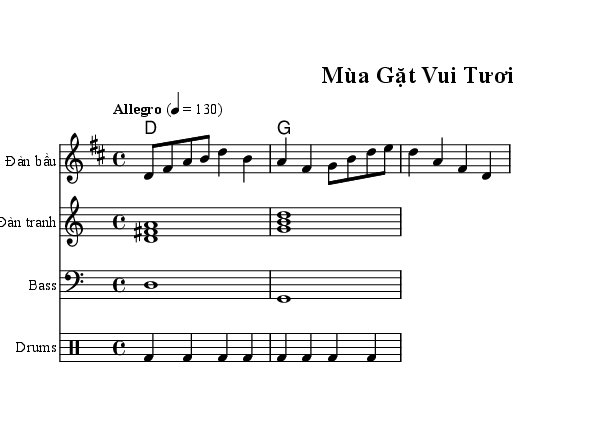What is the title of this music? The title is clearly indicated at the top of the sheet music under the header section. It reads "Mùa Gặt Vui Tươi".
Answer: Mùa Gặt Vui Tươi What is the key signature of this music? The key signature is located in the global definition of the music. The notation specifies "d" which indicates it is in D major.
Answer: D major What is the time signature of this music? The time signature is also found in the global section of the music, where it states "4/4", indicating four beats per measure.
Answer: 4/4 What is the tempo marking of this music? The tempo marking is indicated in the global section as "Allegro" with a metronome marking of "4 = 130", suggesting it should be played fast at 130 beats per minute.
Answer: Allegro, 130 How many measures are in the melody? To determine the number of measures, we need to count the number of sections separated by vertical lines in the melody part. The melody consists of 2 measures as indicated by the notations.
Answer: 2 Which instrument is shown playing the melody? The instrument playing the melody is specified in the staff label which indicates it is "Đàn bầu".
Answer: Đàn bầu What kind of music is this? The characteristics of the song and its title suggest a happy, celebratory tone, typical for "Upbeat Vietnamese dance pop" which celebrates harvest festivals.
Answer: Dance Pop 